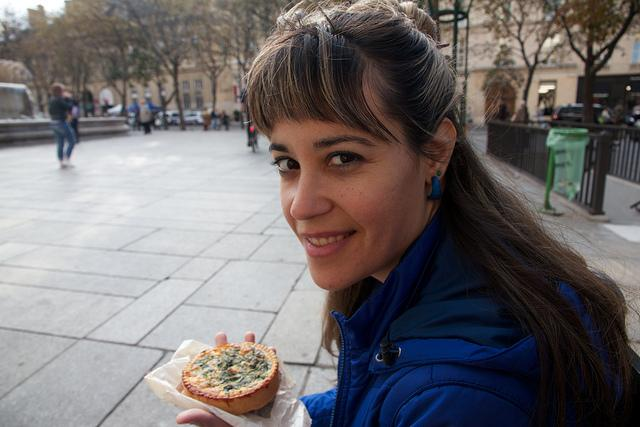What material are the earrings made of? plastic 